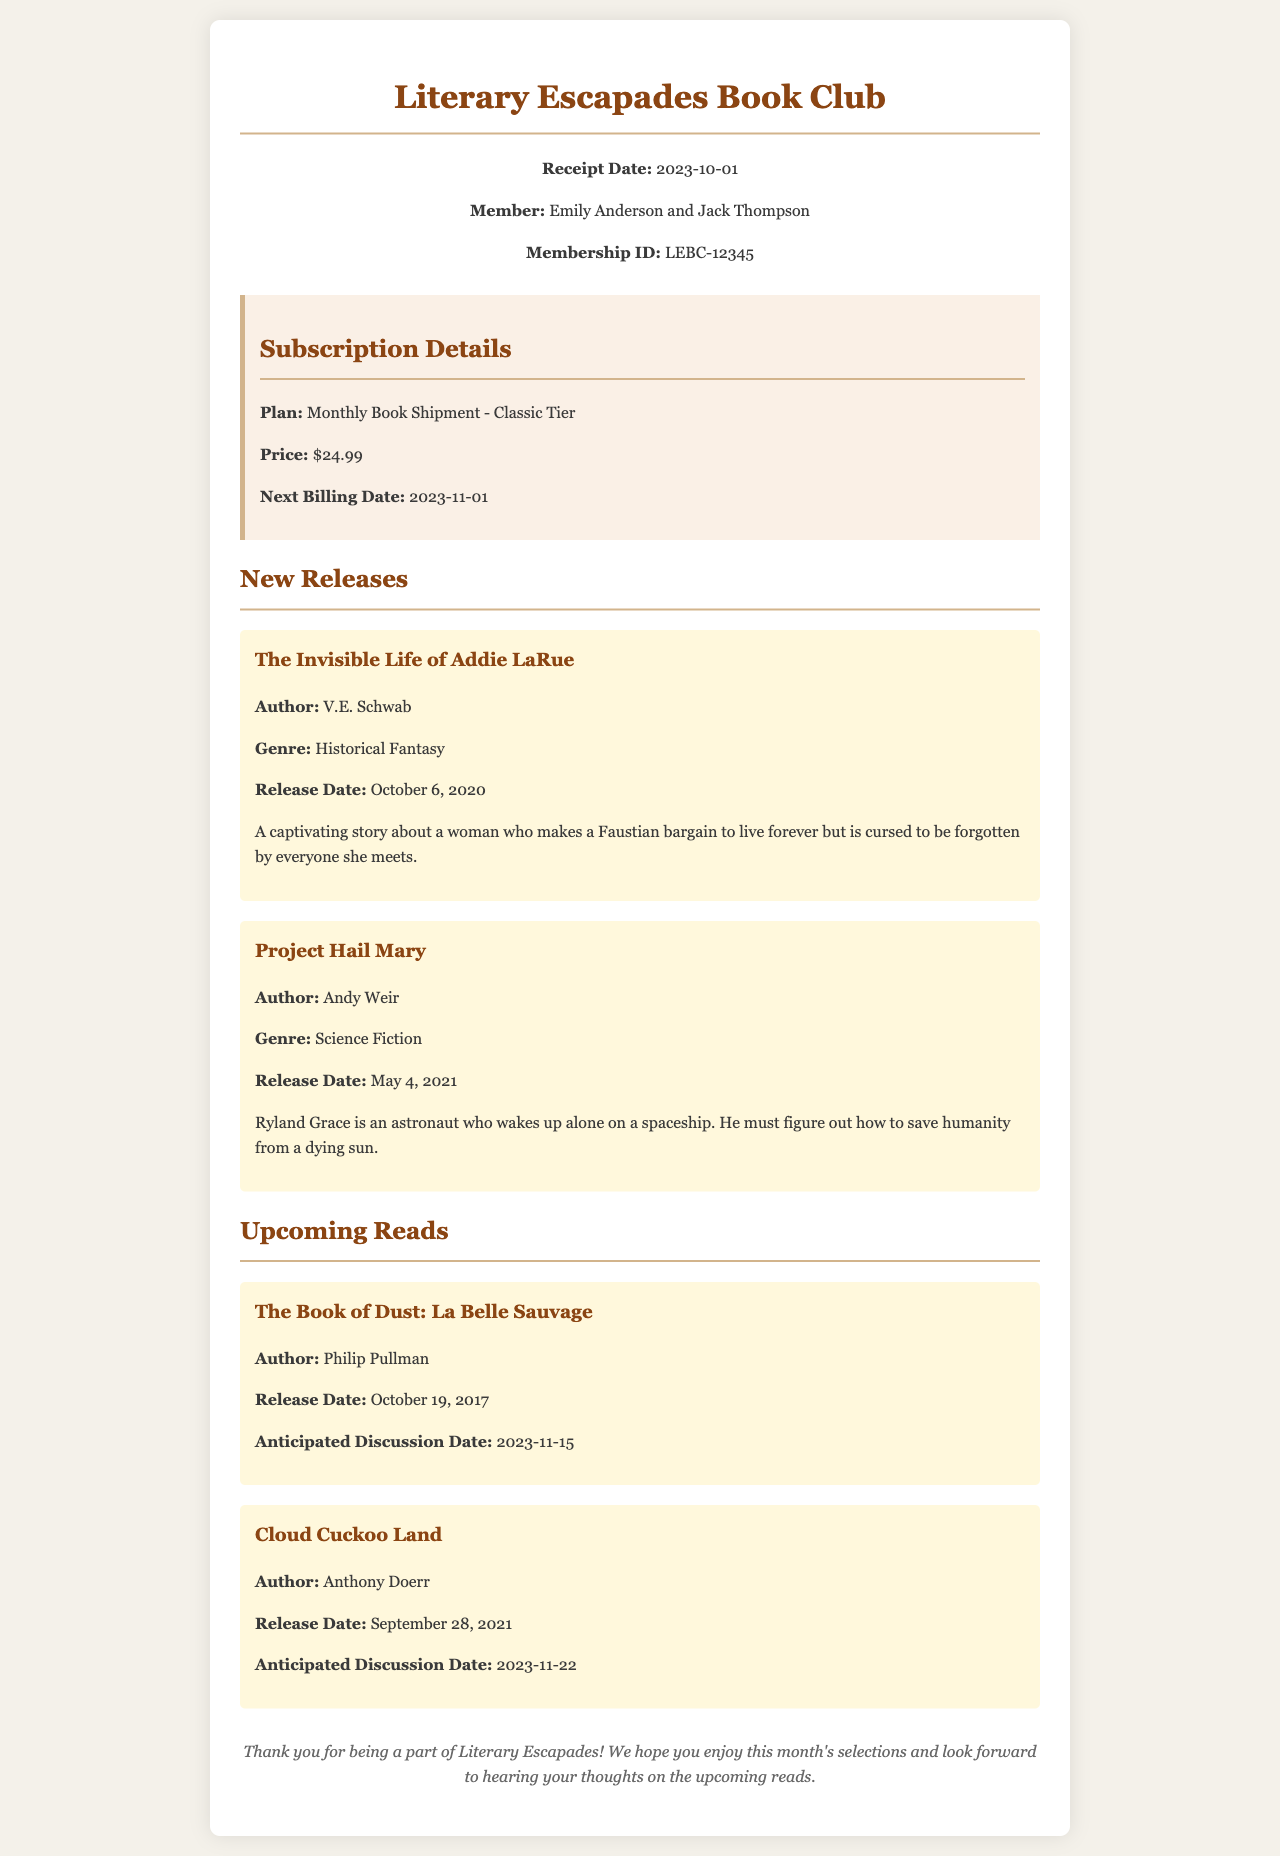What is the member's name? The member's name listed in the document is Emily Anderson and Jack Thompson.
Answer: Emily Anderson and Jack Thompson What is the membership ID? The membership ID provided in the document is LEBC-12345.
Answer: LEBC-12345 What is the next billing date? The next billing date mentioned in the subscription details is 2023-11-01.
Answer: 2023-11-01 Who is the author of "Cloud Cuckoo Land"? The author is noted in the section about upcoming reads, and it's Anthony Doerr.
Answer: Anthony Doerr What genre is "The Invisible Life of Addie LaRue"? The genre is specified in the new releases section as Historical Fantasy.
Answer: Historical Fantasy How much is the monthly subscription price? The price listed for the subscription is found in the subscription details section, which is $24.99.
Answer: $24.99 When is the anticipated discussion date for "The Book of Dust: La Belle Sauvage"? The document indicates that the anticipated discussion date is 2023-11-15.
Answer: 2023-11-15 What is the title of the first new release listed? The first new release mentioned in the document is "The Invisible Life of Addie LaRue."
Answer: The Invisible Life of Addie LaRue What type of membership plan is this receipt for? The document details indicate that it is a Monthly Book Shipment - Classic Tier.
Answer: Monthly Book Shipment - Classic Tier 